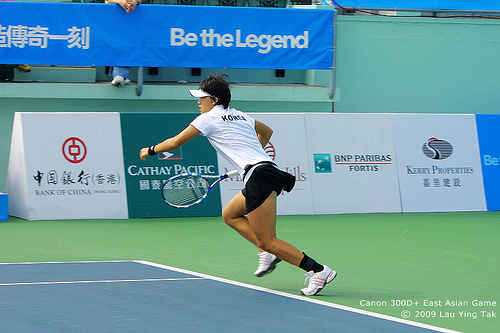Read all the text in this image. Be the elegend BNP PARIBAS 2009 Ying Tak Game Asian East 300D Canon Be KERRTY FORTIS PACIFIC CATHAY CHINA of BANK 